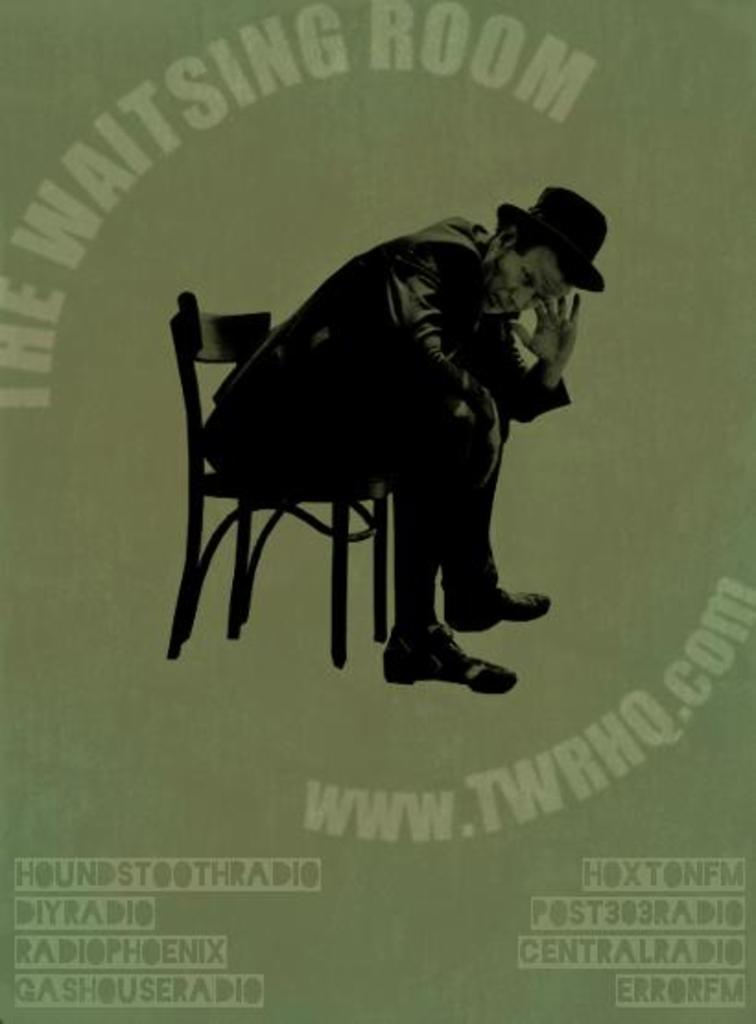What is the main subject of the image? There is an advertisement in the image. What can be seen in the advertisement? There is a person sitting on a chair in the advertisement. What type of coal is being used by the person in the advertisement? There is no coal present in the image, as it features an advertisement with a person sitting on a chair. 